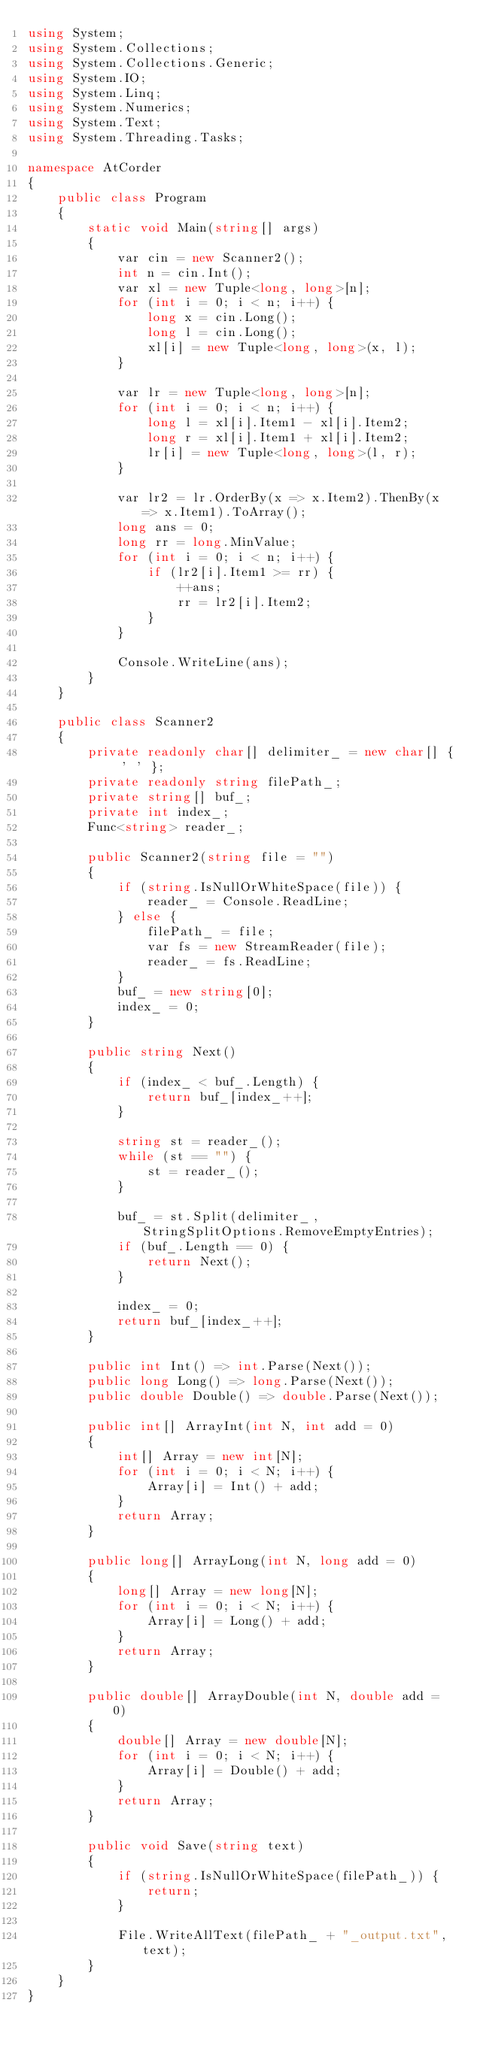Convert code to text. <code><loc_0><loc_0><loc_500><loc_500><_C#_>using System;
using System.Collections;
using System.Collections.Generic;
using System.IO;
using System.Linq;
using System.Numerics;
using System.Text;
using System.Threading.Tasks;

namespace AtCorder
{
	public class Program
	{
		static void Main(string[] args)
		{
			var cin = new Scanner2();
			int n = cin.Int();
			var xl = new Tuple<long, long>[n];
			for (int i = 0; i < n; i++) {
				long x = cin.Long();
				long l = cin.Long();
				xl[i] = new Tuple<long, long>(x, l); 
			}

			var lr = new Tuple<long, long>[n];
			for (int i = 0; i < n; i++) {
				long l = xl[i].Item1 - xl[i].Item2;
				long r = xl[i].Item1 + xl[i].Item2;
				lr[i] = new Tuple<long, long>(l, r);
			}

			var lr2 = lr.OrderBy(x => x.Item2).ThenBy(x => x.Item1).ToArray();
			long ans = 0;
			long rr = long.MinValue;
			for (int i = 0; i < n; i++) {
				if (lr2[i].Item1 >= rr) {
					++ans;
					rr = lr2[i].Item2;
				}
			}

			Console.WriteLine(ans);
		}
	}

	public class Scanner2
	{
		private readonly char[] delimiter_ = new char[] { ' ' };
		private readonly string filePath_;
		private string[] buf_;
		private int index_;
		Func<string> reader_;

		public Scanner2(string file = "")
		{
			if (string.IsNullOrWhiteSpace(file)) {
				reader_ = Console.ReadLine;
			} else {
				filePath_ = file;
				var fs = new StreamReader(file);
				reader_ = fs.ReadLine;
			}
			buf_ = new string[0];
			index_ = 0;
		}

		public string Next()
		{
			if (index_ < buf_.Length) {
				return buf_[index_++];
			}

			string st = reader_();
			while (st == "") {
				st = reader_();
			}

			buf_ = st.Split(delimiter_, StringSplitOptions.RemoveEmptyEntries);
			if (buf_.Length == 0) {
				return Next();
			}

			index_ = 0;
			return buf_[index_++];
		}

		public int Int() => int.Parse(Next());
		public long Long() => long.Parse(Next());
		public double Double() => double.Parse(Next());

		public int[] ArrayInt(int N, int add = 0)
		{
			int[] Array = new int[N];
			for (int i = 0; i < N; i++) {
				Array[i] = Int() + add;
			}
			return Array;
		}

		public long[] ArrayLong(int N, long add = 0)
		{
			long[] Array = new long[N];
			for (int i = 0; i < N; i++) {
				Array[i] = Long() + add;
			}
			return Array;
		}

		public double[] ArrayDouble(int N, double add = 0)
		{
			double[] Array = new double[N];
			for (int i = 0; i < N; i++) {
				Array[i] = Double() + add;
			}
			return Array;
		}

		public void Save(string text)
		{
			if (string.IsNullOrWhiteSpace(filePath_)) {
				return;
			}

			File.WriteAllText(filePath_ + "_output.txt", text);
		}
	}
}</code> 